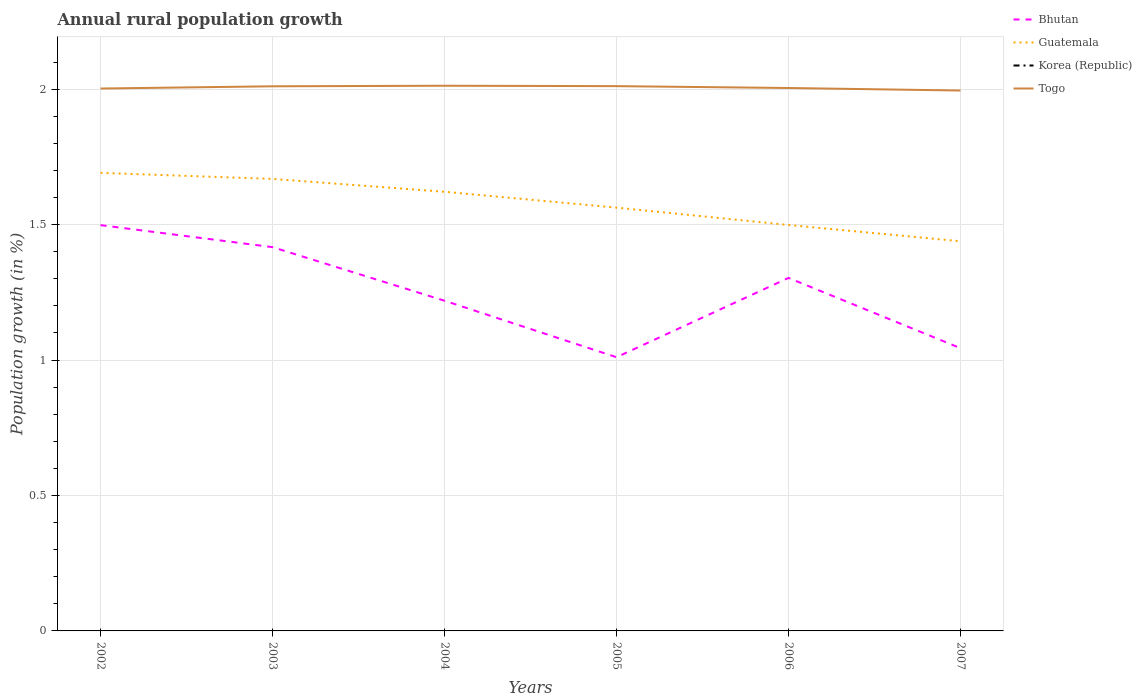Across all years, what is the maximum percentage of rural population growth in Bhutan?
Your response must be concise. 1.01. What is the total percentage of rural population growth in Togo in the graph?
Give a very brief answer. -0.01. What is the difference between the highest and the second highest percentage of rural population growth in Bhutan?
Keep it short and to the point. 0.49. What is the difference between the highest and the lowest percentage of rural population growth in Togo?
Provide a short and direct response. 3. How many lines are there?
Make the answer very short. 3. How many years are there in the graph?
Your response must be concise. 6. Are the values on the major ticks of Y-axis written in scientific E-notation?
Provide a succinct answer. No. Does the graph contain grids?
Offer a terse response. Yes. How many legend labels are there?
Keep it short and to the point. 4. How are the legend labels stacked?
Provide a succinct answer. Vertical. What is the title of the graph?
Offer a terse response. Annual rural population growth. Does "Uganda" appear as one of the legend labels in the graph?
Make the answer very short. No. What is the label or title of the X-axis?
Provide a succinct answer. Years. What is the label or title of the Y-axis?
Make the answer very short. Population growth (in %). What is the Population growth (in %) in Bhutan in 2002?
Keep it short and to the point. 1.5. What is the Population growth (in %) of Guatemala in 2002?
Keep it short and to the point. 1.69. What is the Population growth (in %) of Togo in 2002?
Offer a very short reply. 2. What is the Population growth (in %) of Bhutan in 2003?
Your response must be concise. 1.42. What is the Population growth (in %) in Guatemala in 2003?
Give a very brief answer. 1.67. What is the Population growth (in %) of Togo in 2003?
Provide a succinct answer. 2.01. What is the Population growth (in %) of Bhutan in 2004?
Your answer should be compact. 1.22. What is the Population growth (in %) of Guatemala in 2004?
Give a very brief answer. 1.62. What is the Population growth (in %) in Korea (Republic) in 2004?
Make the answer very short. 0. What is the Population growth (in %) of Togo in 2004?
Provide a short and direct response. 2.01. What is the Population growth (in %) in Bhutan in 2005?
Offer a terse response. 1.01. What is the Population growth (in %) in Guatemala in 2005?
Offer a very short reply. 1.56. What is the Population growth (in %) in Korea (Republic) in 2005?
Offer a terse response. 0. What is the Population growth (in %) in Togo in 2005?
Keep it short and to the point. 2.01. What is the Population growth (in %) of Bhutan in 2006?
Provide a succinct answer. 1.3. What is the Population growth (in %) of Guatemala in 2006?
Provide a short and direct response. 1.5. What is the Population growth (in %) in Korea (Republic) in 2006?
Keep it short and to the point. 0. What is the Population growth (in %) in Togo in 2006?
Provide a succinct answer. 2. What is the Population growth (in %) in Bhutan in 2007?
Offer a terse response. 1.04. What is the Population growth (in %) of Guatemala in 2007?
Make the answer very short. 1.44. What is the Population growth (in %) of Togo in 2007?
Provide a succinct answer. 1.99. Across all years, what is the maximum Population growth (in %) of Bhutan?
Offer a terse response. 1.5. Across all years, what is the maximum Population growth (in %) in Guatemala?
Give a very brief answer. 1.69. Across all years, what is the maximum Population growth (in %) of Togo?
Offer a terse response. 2.01. Across all years, what is the minimum Population growth (in %) of Bhutan?
Make the answer very short. 1.01. Across all years, what is the minimum Population growth (in %) in Guatemala?
Offer a terse response. 1.44. Across all years, what is the minimum Population growth (in %) of Togo?
Provide a short and direct response. 1.99. What is the total Population growth (in %) of Bhutan in the graph?
Your response must be concise. 7.49. What is the total Population growth (in %) of Guatemala in the graph?
Offer a terse response. 9.48. What is the total Population growth (in %) in Korea (Republic) in the graph?
Ensure brevity in your answer.  0. What is the total Population growth (in %) in Togo in the graph?
Make the answer very short. 12.03. What is the difference between the Population growth (in %) in Bhutan in 2002 and that in 2003?
Your answer should be very brief. 0.08. What is the difference between the Population growth (in %) of Guatemala in 2002 and that in 2003?
Make the answer very short. 0.02. What is the difference between the Population growth (in %) in Togo in 2002 and that in 2003?
Your answer should be compact. -0.01. What is the difference between the Population growth (in %) of Bhutan in 2002 and that in 2004?
Your response must be concise. 0.28. What is the difference between the Population growth (in %) in Guatemala in 2002 and that in 2004?
Ensure brevity in your answer.  0.07. What is the difference between the Population growth (in %) in Togo in 2002 and that in 2004?
Give a very brief answer. -0.01. What is the difference between the Population growth (in %) in Bhutan in 2002 and that in 2005?
Provide a short and direct response. 0.49. What is the difference between the Population growth (in %) in Guatemala in 2002 and that in 2005?
Ensure brevity in your answer.  0.13. What is the difference between the Population growth (in %) of Togo in 2002 and that in 2005?
Ensure brevity in your answer.  -0.01. What is the difference between the Population growth (in %) in Bhutan in 2002 and that in 2006?
Provide a succinct answer. 0.19. What is the difference between the Population growth (in %) in Guatemala in 2002 and that in 2006?
Your response must be concise. 0.19. What is the difference between the Population growth (in %) of Togo in 2002 and that in 2006?
Offer a terse response. -0. What is the difference between the Population growth (in %) in Bhutan in 2002 and that in 2007?
Offer a very short reply. 0.45. What is the difference between the Population growth (in %) of Guatemala in 2002 and that in 2007?
Offer a terse response. 0.25. What is the difference between the Population growth (in %) in Togo in 2002 and that in 2007?
Keep it short and to the point. 0.01. What is the difference between the Population growth (in %) of Bhutan in 2003 and that in 2004?
Give a very brief answer. 0.2. What is the difference between the Population growth (in %) of Guatemala in 2003 and that in 2004?
Ensure brevity in your answer.  0.05. What is the difference between the Population growth (in %) in Togo in 2003 and that in 2004?
Make the answer very short. -0. What is the difference between the Population growth (in %) in Bhutan in 2003 and that in 2005?
Offer a terse response. 0.41. What is the difference between the Population growth (in %) in Guatemala in 2003 and that in 2005?
Make the answer very short. 0.11. What is the difference between the Population growth (in %) in Togo in 2003 and that in 2005?
Make the answer very short. -0. What is the difference between the Population growth (in %) of Bhutan in 2003 and that in 2006?
Your answer should be very brief. 0.11. What is the difference between the Population growth (in %) in Guatemala in 2003 and that in 2006?
Your answer should be compact. 0.17. What is the difference between the Population growth (in %) of Togo in 2003 and that in 2006?
Your answer should be very brief. 0.01. What is the difference between the Population growth (in %) in Bhutan in 2003 and that in 2007?
Offer a terse response. 0.37. What is the difference between the Population growth (in %) in Guatemala in 2003 and that in 2007?
Provide a short and direct response. 0.23. What is the difference between the Population growth (in %) in Togo in 2003 and that in 2007?
Your answer should be compact. 0.02. What is the difference between the Population growth (in %) in Bhutan in 2004 and that in 2005?
Your response must be concise. 0.21. What is the difference between the Population growth (in %) of Guatemala in 2004 and that in 2005?
Give a very brief answer. 0.06. What is the difference between the Population growth (in %) in Togo in 2004 and that in 2005?
Provide a short and direct response. 0. What is the difference between the Population growth (in %) in Bhutan in 2004 and that in 2006?
Make the answer very short. -0.08. What is the difference between the Population growth (in %) in Guatemala in 2004 and that in 2006?
Provide a short and direct response. 0.12. What is the difference between the Population growth (in %) of Togo in 2004 and that in 2006?
Offer a very short reply. 0.01. What is the difference between the Population growth (in %) in Bhutan in 2004 and that in 2007?
Your answer should be compact. 0.18. What is the difference between the Population growth (in %) in Guatemala in 2004 and that in 2007?
Your response must be concise. 0.18. What is the difference between the Population growth (in %) in Togo in 2004 and that in 2007?
Give a very brief answer. 0.02. What is the difference between the Population growth (in %) of Bhutan in 2005 and that in 2006?
Your answer should be compact. -0.29. What is the difference between the Population growth (in %) in Guatemala in 2005 and that in 2006?
Provide a short and direct response. 0.06. What is the difference between the Population growth (in %) in Togo in 2005 and that in 2006?
Your answer should be compact. 0.01. What is the difference between the Population growth (in %) of Bhutan in 2005 and that in 2007?
Your answer should be very brief. -0.03. What is the difference between the Population growth (in %) in Guatemala in 2005 and that in 2007?
Offer a terse response. 0.12. What is the difference between the Population growth (in %) of Togo in 2005 and that in 2007?
Provide a succinct answer. 0.02. What is the difference between the Population growth (in %) of Bhutan in 2006 and that in 2007?
Your answer should be compact. 0.26. What is the difference between the Population growth (in %) in Guatemala in 2006 and that in 2007?
Your response must be concise. 0.06. What is the difference between the Population growth (in %) in Togo in 2006 and that in 2007?
Your answer should be compact. 0.01. What is the difference between the Population growth (in %) in Bhutan in 2002 and the Population growth (in %) in Guatemala in 2003?
Offer a very short reply. -0.17. What is the difference between the Population growth (in %) of Bhutan in 2002 and the Population growth (in %) of Togo in 2003?
Your answer should be very brief. -0.51. What is the difference between the Population growth (in %) in Guatemala in 2002 and the Population growth (in %) in Togo in 2003?
Your response must be concise. -0.32. What is the difference between the Population growth (in %) in Bhutan in 2002 and the Population growth (in %) in Guatemala in 2004?
Your answer should be compact. -0.12. What is the difference between the Population growth (in %) of Bhutan in 2002 and the Population growth (in %) of Togo in 2004?
Give a very brief answer. -0.51. What is the difference between the Population growth (in %) of Guatemala in 2002 and the Population growth (in %) of Togo in 2004?
Provide a short and direct response. -0.32. What is the difference between the Population growth (in %) in Bhutan in 2002 and the Population growth (in %) in Guatemala in 2005?
Give a very brief answer. -0.06. What is the difference between the Population growth (in %) in Bhutan in 2002 and the Population growth (in %) in Togo in 2005?
Offer a very short reply. -0.51. What is the difference between the Population growth (in %) of Guatemala in 2002 and the Population growth (in %) of Togo in 2005?
Your answer should be very brief. -0.32. What is the difference between the Population growth (in %) in Bhutan in 2002 and the Population growth (in %) in Guatemala in 2006?
Give a very brief answer. -0. What is the difference between the Population growth (in %) of Bhutan in 2002 and the Population growth (in %) of Togo in 2006?
Offer a terse response. -0.51. What is the difference between the Population growth (in %) of Guatemala in 2002 and the Population growth (in %) of Togo in 2006?
Provide a short and direct response. -0.31. What is the difference between the Population growth (in %) of Bhutan in 2002 and the Population growth (in %) of Guatemala in 2007?
Give a very brief answer. 0.06. What is the difference between the Population growth (in %) of Bhutan in 2002 and the Population growth (in %) of Togo in 2007?
Provide a succinct answer. -0.5. What is the difference between the Population growth (in %) in Guatemala in 2002 and the Population growth (in %) in Togo in 2007?
Provide a succinct answer. -0.3. What is the difference between the Population growth (in %) in Bhutan in 2003 and the Population growth (in %) in Guatemala in 2004?
Keep it short and to the point. -0.2. What is the difference between the Population growth (in %) of Bhutan in 2003 and the Population growth (in %) of Togo in 2004?
Ensure brevity in your answer.  -0.6. What is the difference between the Population growth (in %) in Guatemala in 2003 and the Population growth (in %) in Togo in 2004?
Your answer should be very brief. -0.34. What is the difference between the Population growth (in %) of Bhutan in 2003 and the Population growth (in %) of Guatemala in 2005?
Provide a succinct answer. -0.15. What is the difference between the Population growth (in %) in Bhutan in 2003 and the Population growth (in %) in Togo in 2005?
Keep it short and to the point. -0.59. What is the difference between the Population growth (in %) in Guatemala in 2003 and the Population growth (in %) in Togo in 2005?
Give a very brief answer. -0.34. What is the difference between the Population growth (in %) in Bhutan in 2003 and the Population growth (in %) in Guatemala in 2006?
Offer a very short reply. -0.08. What is the difference between the Population growth (in %) in Bhutan in 2003 and the Population growth (in %) in Togo in 2006?
Offer a terse response. -0.59. What is the difference between the Population growth (in %) in Guatemala in 2003 and the Population growth (in %) in Togo in 2006?
Your answer should be very brief. -0.34. What is the difference between the Population growth (in %) of Bhutan in 2003 and the Population growth (in %) of Guatemala in 2007?
Your answer should be compact. -0.02. What is the difference between the Population growth (in %) of Bhutan in 2003 and the Population growth (in %) of Togo in 2007?
Offer a terse response. -0.58. What is the difference between the Population growth (in %) in Guatemala in 2003 and the Population growth (in %) in Togo in 2007?
Give a very brief answer. -0.33. What is the difference between the Population growth (in %) in Bhutan in 2004 and the Population growth (in %) in Guatemala in 2005?
Provide a short and direct response. -0.34. What is the difference between the Population growth (in %) in Bhutan in 2004 and the Population growth (in %) in Togo in 2005?
Give a very brief answer. -0.79. What is the difference between the Population growth (in %) in Guatemala in 2004 and the Population growth (in %) in Togo in 2005?
Offer a very short reply. -0.39. What is the difference between the Population growth (in %) of Bhutan in 2004 and the Population growth (in %) of Guatemala in 2006?
Offer a very short reply. -0.28. What is the difference between the Population growth (in %) of Bhutan in 2004 and the Population growth (in %) of Togo in 2006?
Your answer should be very brief. -0.79. What is the difference between the Population growth (in %) in Guatemala in 2004 and the Population growth (in %) in Togo in 2006?
Your answer should be very brief. -0.38. What is the difference between the Population growth (in %) in Bhutan in 2004 and the Population growth (in %) in Guatemala in 2007?
Ensure brevity in your answer.  -0.22. What is the difference between the Population growth (in %) of Bhutan in 2004 and the Population growth (in %) of Togo in 2007?
Give a very brief answer. -0.78. What is the difference between the Population growth (in %) of Guatemala in 2004 and the Population growth (in %) of Togo in 2007?
Keep it short and to the point. -0.37. What is the difference between the Population growth (in %) in Bhutan in 2005 and the Population growth (in %) in Guatemala in 2006?
Provide a short and direct response. -0.49. What is the difference between the Population growth (in %) of Bhutan in 2005 and the Population growth (in %) of Togo in 2006?
Your answer should be compact. -0.99. What is the difference between the Population growth (in %) in Guatemala in 2005 and the Population growth (in %) in Togo in 2006?
Your response must be concise. -0.44. What is the difference between the Population growth (in %) in Bhutan in 2005 and the Population growth (in %) in Guatemala in 2007?
Offer a very short reply. -0.43. What is the difference between the Population growth (in %) in Bhutan in 2005 and the Population growth (in %) in Togo in 2007?
Your answer should be compact. -0.98. What is the difference between the Population growth (in %) of Guatemala in 2005 and the Population growth (in %) of Togo in 2007?
Give a very brief answer. -0.43. What is the difference between the Population growth (in %) in Bhutan in 2006 and the Population growth (in %) in Guatemala in 2007?
Keep it short and to the point. -0.14. What is the difference between the Population growth (in %) of Bhutan in 2006 and the Population growth (in %) of Togo in 2007?
Your answer should be very brief. -0.69. What is the difference between the Population growth (in %) in Guatemala in 2006 and the Population growth (in %) in Togo in 2007?
Your response must be concise. -0.5. What is the average Population growth (in %) in Bhutan per year?
Ensure brevity in your answer.  1.25. What is the average Population growth (in %) in Guatemala per year?
Make the answer very short. 1.58. What is the average Population growth (in %) in Korea (Republic) per year?
Make the answer very short. 0. What is the average Population growth (in %) in Togo per year?
Give a very brief answer. 2.01. In the year 2002, what is the difference between the Population growth (in %) of Bhutan and Population growth (in %) of Guatemala?
Offer a very short reply. -0.19. In the year 2002, what is the difference between the Population growth (in %) in Bhutan and Population growth (in %) in Togo?
Offer a terse response. -0.5. In the year 2002, what is the difference between the Population growth (in %) of Guatemala and Population growth (in %) of Togo?
Your answer should be compact. -0.31. In the year 2003, what is the difference between the Population growth (in %) in Bhutan and Population growth (in %) in Guatemala?
Ensure brevity in your answer.  -0.25. In the year 2003, what is the difference between the Population growth (in %) in Bhutan and Population growth (in %) in Togo?
Offer a terse response. -0.59. In the year 2003, what is the difference between the Population growth (in %) of Guatemala and Population growth (in %) of Togo?
Make the answer very short. -0.34. In the year 2004, what is the difference between the Population growth (in %) of Bhutan and Population growth (in %) of Guatemala?
Give a very brief answer. -0.4. In the year 2004, what is the difference between the Population growth (in %) of Bhutan and Population growth (in %) of Togo?
Offer a very short reply. -0.79. In the year 2004, what is the difference between the Population growth (in %) of Guatemala and Population growth (in %) of Togo?
Your response must be concise. -0.39. In the year 2005, what is the difference between the Population growth (in %) of Bhutan and Population growth (in %) of Guatemala?
Provide a short and direct response. -0.55. In the year 2005, what is the difference between the Population growth (in %) in Bhutan and Population growth (in %) in Togo?
Ensure brevity in your answer.  -1. In the year 2005, what is the difference between the Population growth (in %) of Guatemala and Population growth (in %) of Togo?
Your answer should be very brief. -0.45. In the year 2006, what is the difference between the Population growth (in %) of Bhutan and Population growth (in %) of Guatemala?
Offer a terse response. -0.2. In the year 2006, what is the difference between the Population growth (in %) in Bhutan and Population growth (in %) in Togo?
Offer a very short reply. -0.7. In the year 2006, what is the difference between the Population growth (in %) in Guatemala and Population growth (in %) in Togo?
Offer a very short reply. -0.51. In the year 2007, what is the difference between the Population growth (in %) in Bhutan and Population growth (in %) in Guatemala?
Offer a very short reply. -0.39. In the year 2007, what is the difference between the Population growth (in %) in Bhutan and Population growth (in %) in Togo?
Provide a short and direct response. -0.95. In the year 2007, what is the difference between the Population growth (in %) in Guatemala and Population growth (in %) in Togo?
Offer a terse response. -0.56. What is the ratio of the Population growth (in %) of Bhutan in 2002 to that in 2003?
Your answer should be very brief. 1.06. What is the ratio of the Population growth (in %) in Guatemala in 2002 to that in 2003?
Ensure brevity in your answer.  1.01. What is the ratio of the Population growth (in %) of Togo in 2002 to that in 2003?
Offer a terse response. 1. What is the ratio of the Population growth (in %) in Bhutan in 2002 to that in 2004?
Your answer should be very brief. 1.23. What is the ratio of the Population growth (in %) in Guatemala in 2002 to that in 2004?
Provide a succinct answer. 1.04. What is the ratio of the Population growth (in %) in Bhutan in 2002 to that in 2005?
Ensure brevity in your answer.  1.48. What is the ratio of the Population growth (in %) in Guatemala in 2002 to that in 2005?
Your answer should be compact. 1.08. What is the ratio of the Population growth (in %) of Togo in 2002 to that in 2005?
Keep it short and to the point. 1. What is the ratio of the Population growth (in %) of Bhutan in 2002 to that in 2006?
Make the answer very short. 1.15. What is the ratio of the Population growth (in %) in Guatemala in 2002 to that in 2006?
Your response must be concise. 1.13. What is the ratio of the Population growth (in %) in Togo in 2002 to that in 2006?
Offer a terse response. 1. What is the ratio of the Population growth (in %) of Bhutan in 2002 to that in 2007?
Ensure brevity in your answer.  1.44. What is the ratio of the Population growth (in %) in Guatemala in 2002 to that in 2007?
Offer a terse response. 1.18. What is the ratio of the Population growth (in %) in Bhutan in 2003 to that in 2004?
Your answer should be very brief. 1.16. What is the ratio of the Population growth (in %) in Guatemala in 2003 to that in 2004?
Your answer should be very brief. 1.03. What is the ratio of the Population growth (in %) in Togo in 2003 to that in 2004?
Your answer should be very brief. 1. What is the ratio of the Population growth (in %) of Bhutan in 2003 to that in 2005?
Your answer should be very brief. 1.4. What is the ratio of the Population growth (in %) in Guatemala in 2003 to that in 2005?
Your answer should be very brief. 1.07. What is the ratio of the Population growth (in %) in Togo in 2003 to that in 2005?
Your answer should be very brief. 1. What is the ratio of the Population growth (in %) in Bhutan in 2003 to that in 2006?
Your response must be concise. 1.09. What is the ratio of the Population growth (in %) in Guatemala in 2003 to that in 2006?
Your response must be concise. 1.11. What is the ratio of the Population growth (in %) in Togo in 2003 to that in 2006?
Give a very brief answer. 1. What is the ratio of the Population growth (in %) in Bhutan in 2003 to that in 2007?
Your response must be concise. 1.36. What is the ratio of the Population growth (in %) of Guatemala in 2003 to that in 2007?
Offer a terse response. 1.16. What is the ratio of the Population growth (in %) of Togo in 2003 to that in 2007?
Your answer should be compact. 1.01. What is the ratio of the Population growth (in %) in Bhutan in 2004 to that in 2005?
Keep it short and to the point. 1.21. What is the ratio of the Population growth (in %) of Guatemala in 2004 to that in 2005?
Provide a succinct answer. 1.04. What is the ratio of the Population growth (in %) of Bhutan in 2004 to that in 2006?
Ensure brevity in your answer.  0.94. What is the ratio of the Population growth (in %) in Guatemala in 2004 to that in 2006?
Give a very brief answer. 1.08. What is the ratio of the Population growth (in %) in Togo in 2004 to that in 2006?
Provide a succinct answer. 1. What is the ratio of the Population growth (in %) in Bhutan in 2004 to that in 2007?
Your answer should be compact. 1.17. What is the ratio of the Population growth (in %) in Guatemala in 2004 to that in 2007?
Your answer should be compact. 1.13. What is the ratio of the Population growth (in %) in Togo in 2004 to that in 2007?
Your response must be concise. 1.01. What is the ratio of the Population growth (in %) in Bhutan in 2005 to that in 2006?
Keep it short and to the point. 0.78. What is the ratio of the Population growth (in %) in Guatemala in 2005 to that in 2006?
Ensure brevity in your answer.  1.04. What is the ratio of the Population growth (in %) in Togo in 2005 to that in 2006?
Provide a succinct answer. 1. What is the ratio of the Population growth (in %) of Bhutan in 2005 to that in 2007?
Provide a succinct answer. 0.97. What is the ratio of the Population growth (in %) of Guatemala in 2005 to that in 2007?
Provide a succinct answer. 1.09. What is the ratio of the Population growth (in %) of Bhutan in 2006 to that in 2007?
Offer a very short reply. 1.25. What is the ratio of the Population growth (in %) in Guatemala in 2006 to that in 2007?
Your answer should be very brief. 1.04. What is the difference between the highest and the second highest Population growth (in %) of Bhutan?
Provide a succinct answer. 0.08. What is the difference between the highest and the second highest Population growth (in %) in Guatemala?
Keep it short and to the point. 0.02. What is the difference between the highest and the second highest Population growth (in %) of Togo?
Offer a terse response. 0. What is the difference between the highest and the lowest Population growth (in %) of Bhutan?
Ensure brevity in your answer.  0.49. What is the difference between the highest and the lowest Population growth (in %) in Guatemala?
Your response must be concise. 0.25. What is the difference between the highest and the lowest Population growth (in %) in Togo?
Offer a terse response. 0.02. 